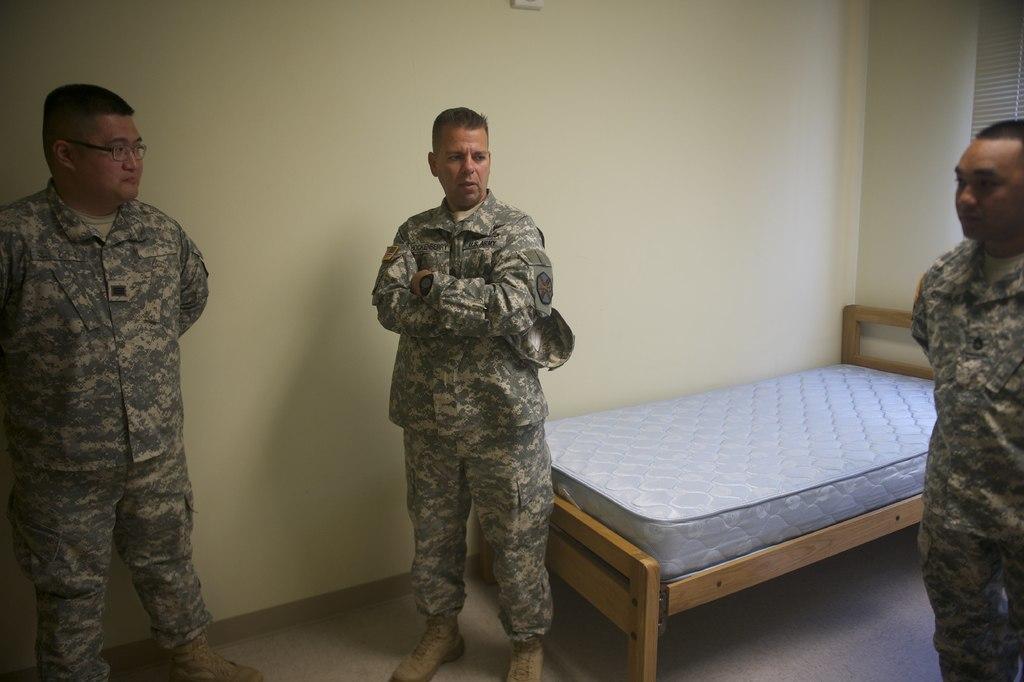Describe this image in one or two sentences. There are three persons standing and there is a bed behind them and the background wall is cream in color. 